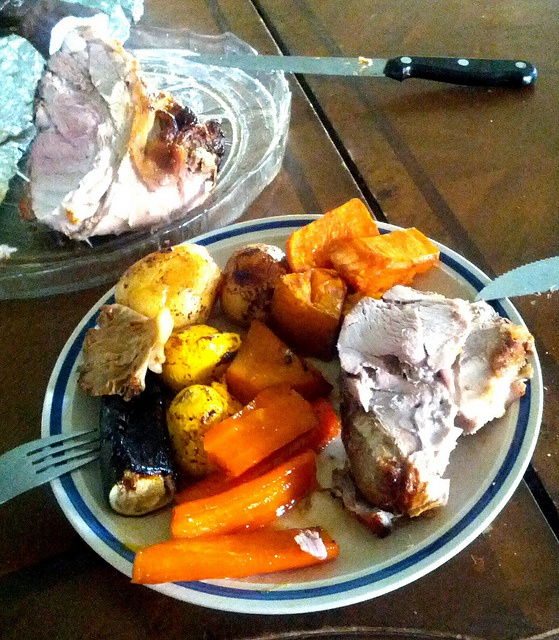Describe the objects in this image and their specific colors. I can see dining table in black, olive, white, darkgray, and maroon tones, cake in teal, white, darkgray, black, and maroon tones, cake in teal, white, darkgray, and tan tones, knife in teal, black, darkgray, and gray tones, and carrot in teal, red, orange, lightgray, and brown tones in this image. 